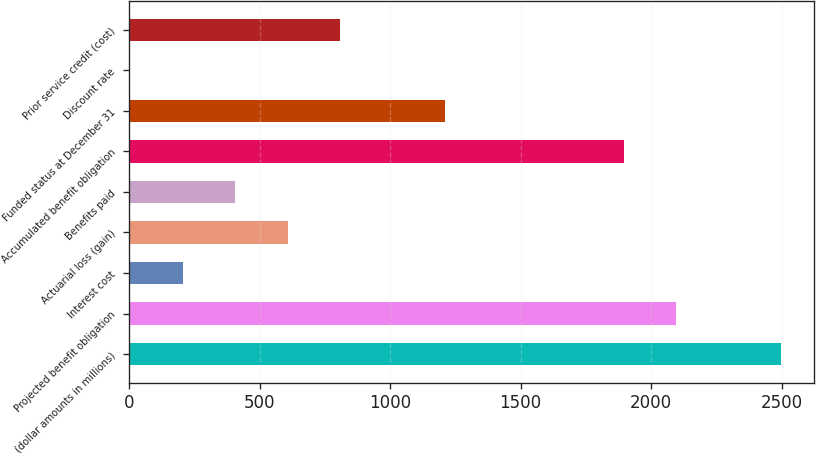Convert chart. <chart><loc_0><loc_0><loc_500><loc_500><bar_chart><fcel>(dollar amounts in millions)<fcel>Projected benefit obligation<fcel>Interest cost<fcel>Actuarial loss (gain)<fcel>Benefits paid<fcel>Accumulated benefit obligation<fcel>Funded status at December 31<fcel>Discount rate<fcel>Prior service credit (cost)<nl><fcel>2497.54<fcel>2095.18<fcel>205.41<fcel>607.77<fcel>406.59<fcel>1894<fcel>1211.31<fcel>4.23<fcel>808.95<nl></chart> 